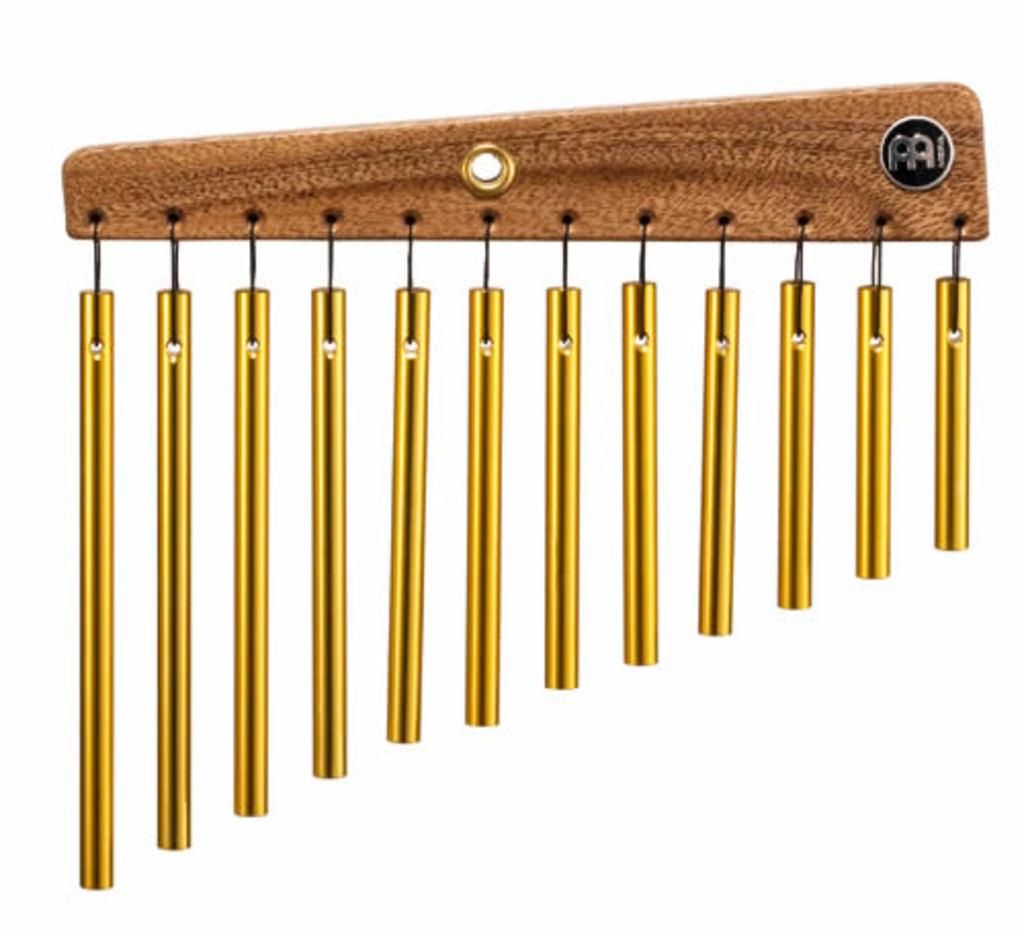What type of object is featured in the image? There are gold color chimes in the image. How are the chimes supported or held up? The chimes are hanged on a wooden stick. What color is the background of the image? The background of the image is white. What shape is the sock in the image? There is no sock present in the image; it features gold color chimes hung on a wooden stick with a white background. 